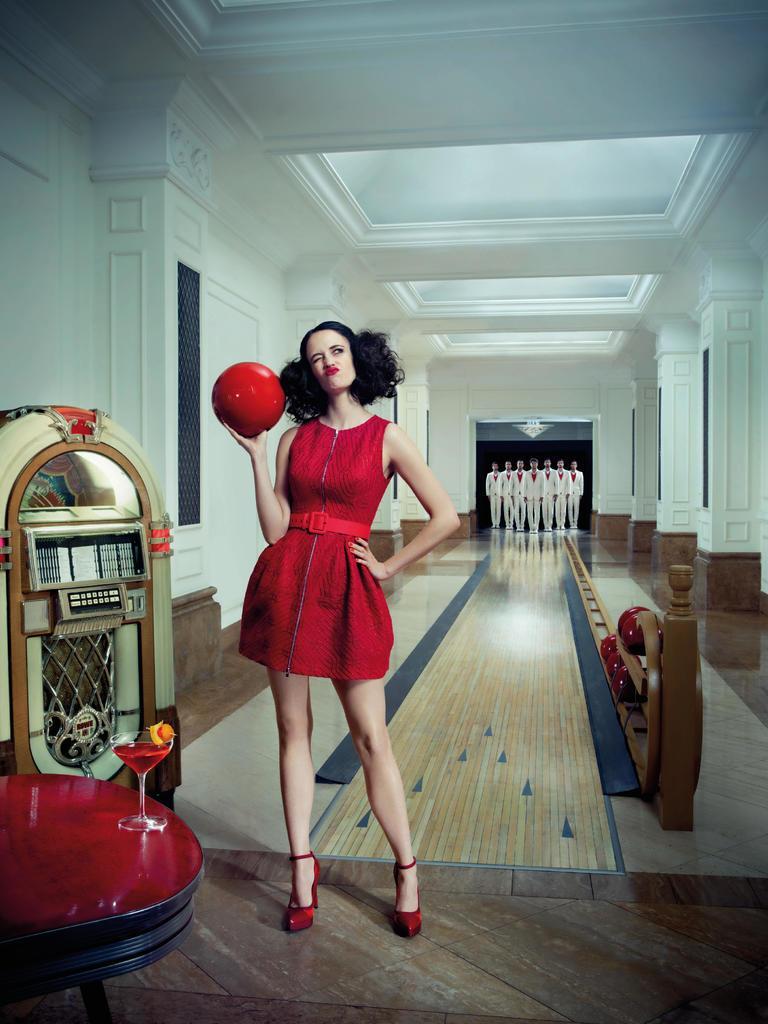Describe this image in one or two sentences. In the center of the picture there is a woman in red dress holding a ball. On the left there are tabulated, machine and drink. In the center of the picture there is bowling track. In the background there are men. At the top, it is ceilings painted white. 